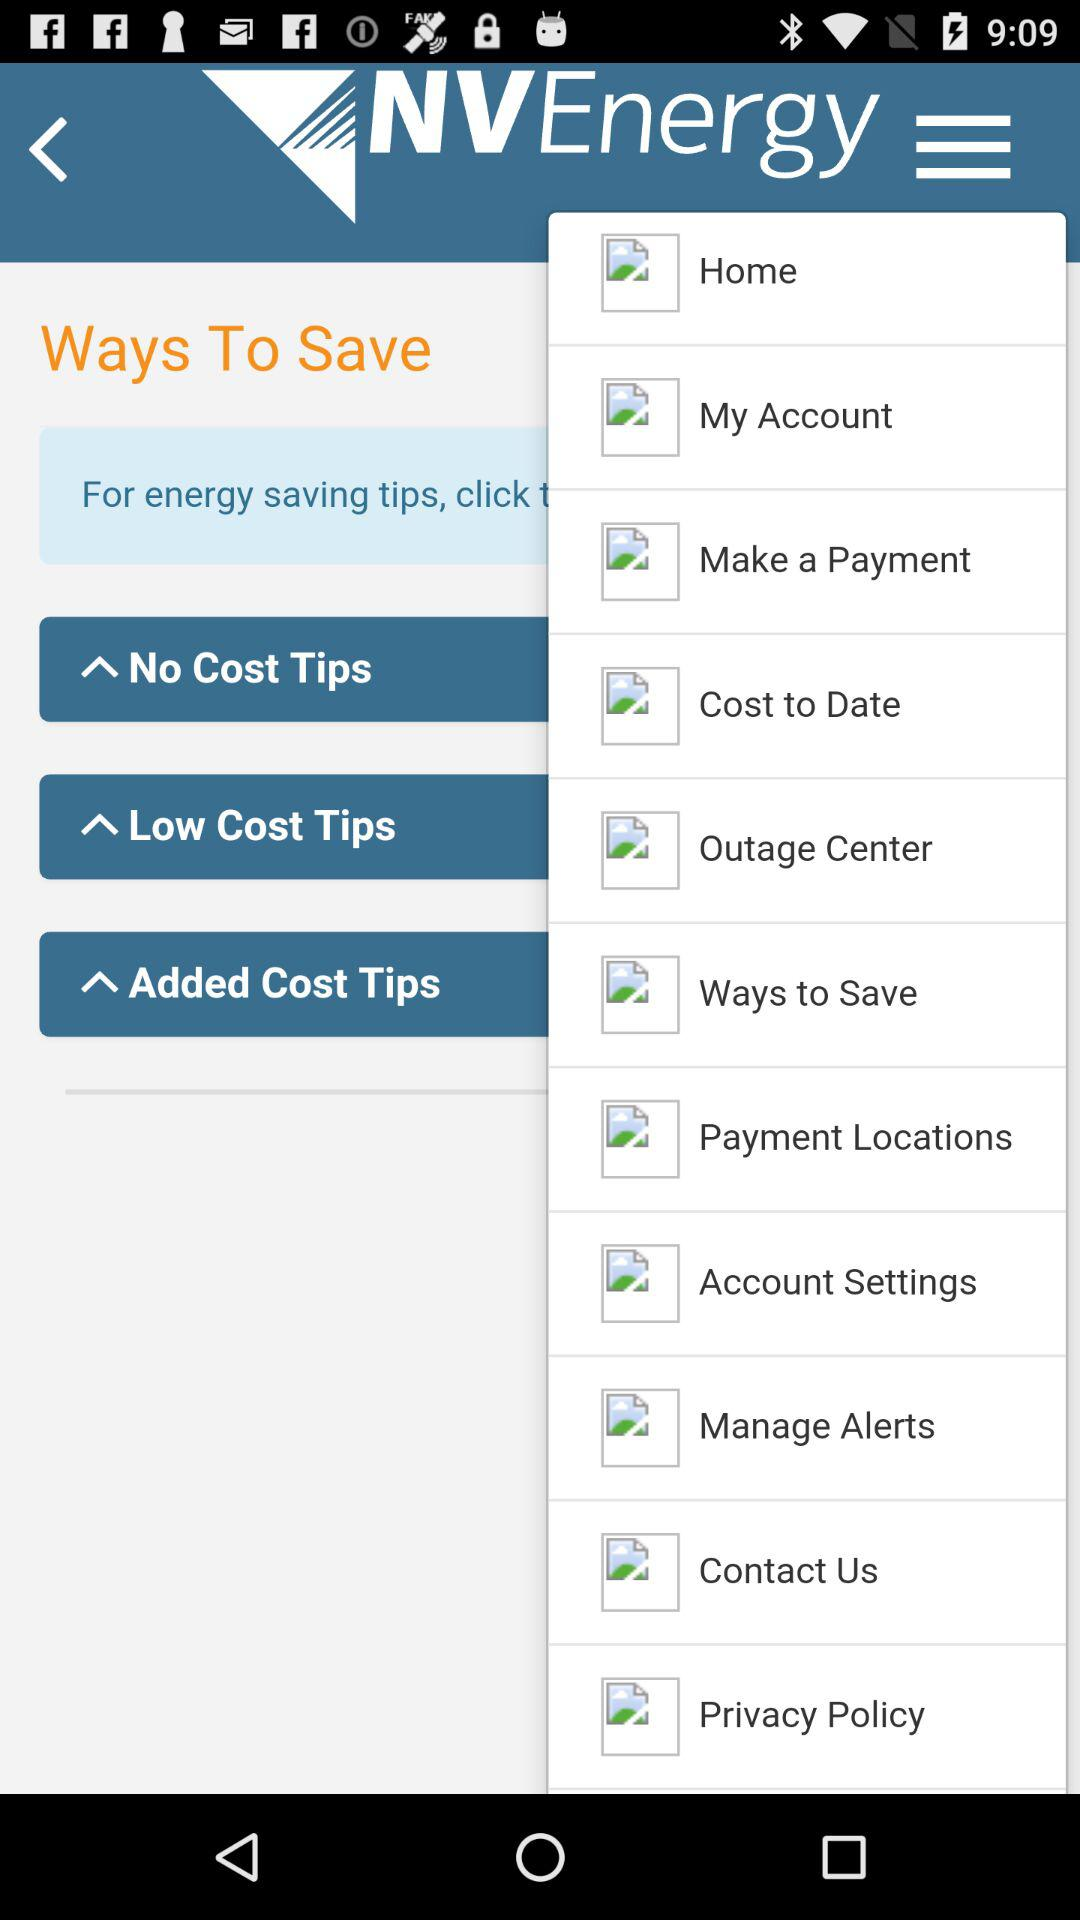What is the app name? The app name is "NVEnergy". 